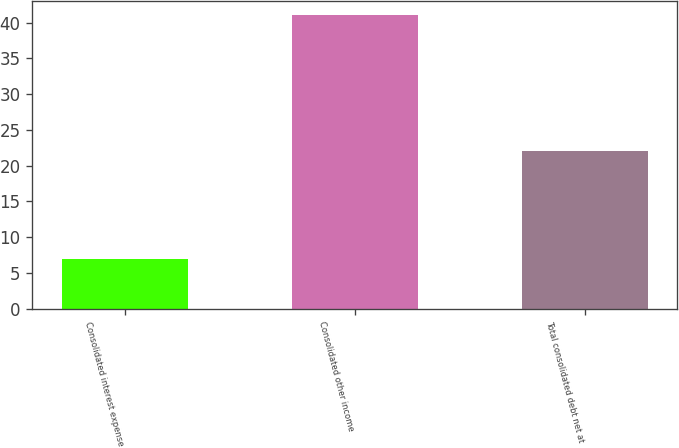<chart> <loc_0><loc_0><loc_500><loc_500><bar_chart><fcel>Consolidated interest expense<fcel>Consolidated other income<fcel>Total consolidated debt net at<nl><fcel>7<fcel>41<fcel>22<nl></chart> 